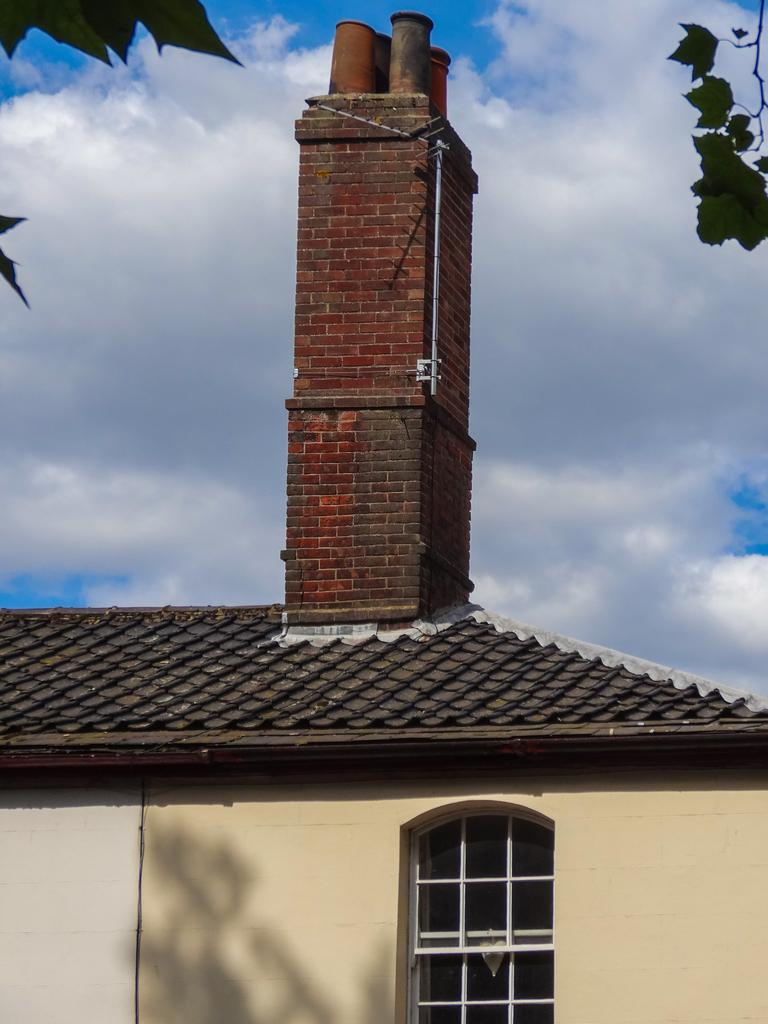What can be seen in the background of the image? The sky is visible in the image. What type of structure is present in the image? There is a building in the image. What type of vegetation is present in the image? Leaves of a tree are present in the image. What type of frame is holding the leaves in the image? There is no frame present in the image; the leaves are part of a tree. What mineral can be seen in the image? There is no mineral, such as quartz, present in the image. 